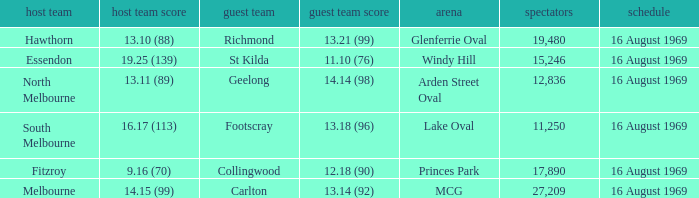When was the game played at Lake Oval? 16 August 1969. 